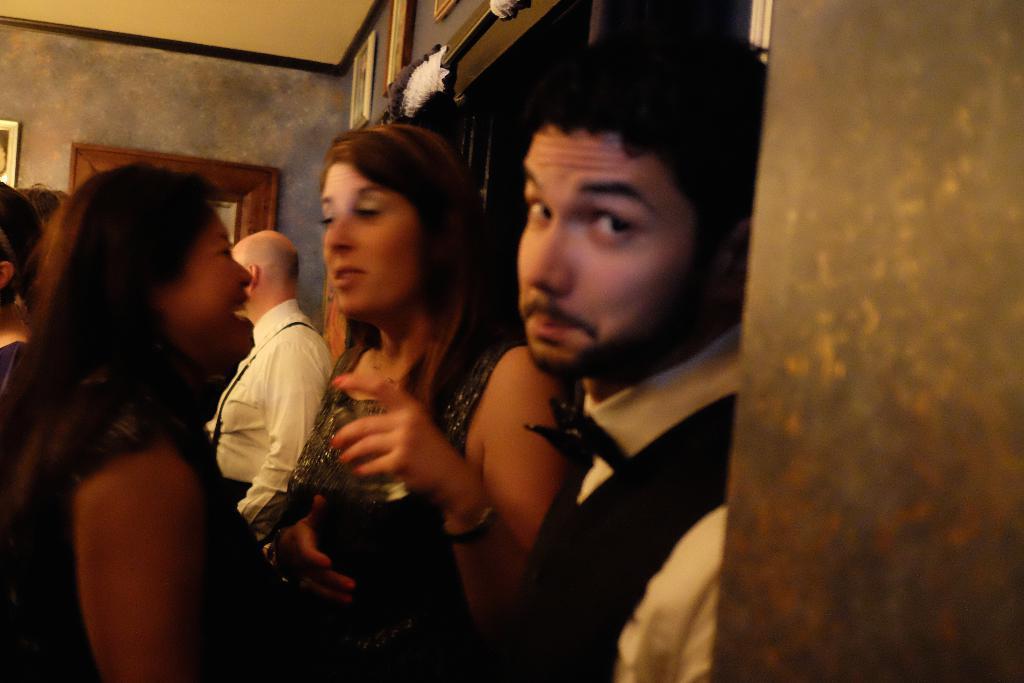How would you summarize this image in a sentence or two? In this picture we can see there some people standing and behind the people there is a wall with photo frames. 